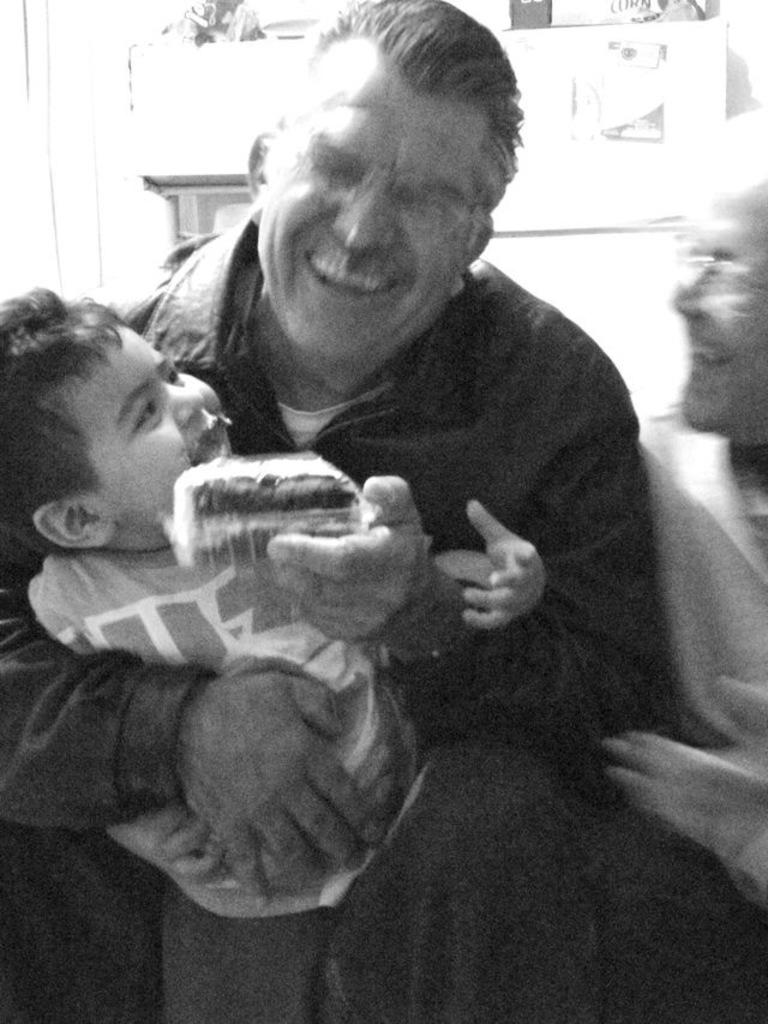How many people are in the image? There are three members in the image. Can you describe the age range of the people in the image? Two of them are adults, and one of them is a kid. What is the general expression of the people in the image? All of them are smiling. What is the color scheme of the image? The image is black and white. What type of sand can be seen blowing in the image? There is no sand or blowing motion present in the image. 